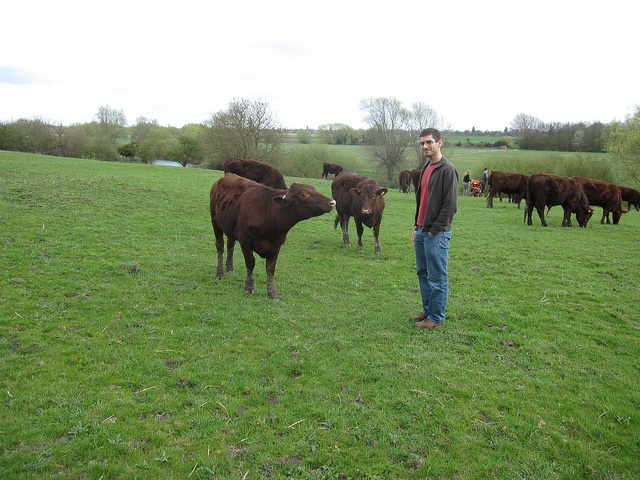Describe the objects in this image and their specific colors. I can see cow in white, black, and gray tones, people in white, black, gray, blue, and darkblue tones, cow in white, black, and gray tones, cow in white, black, maroon, and gray tones, and cow in white, black, maroon, and gray tones in this image. 